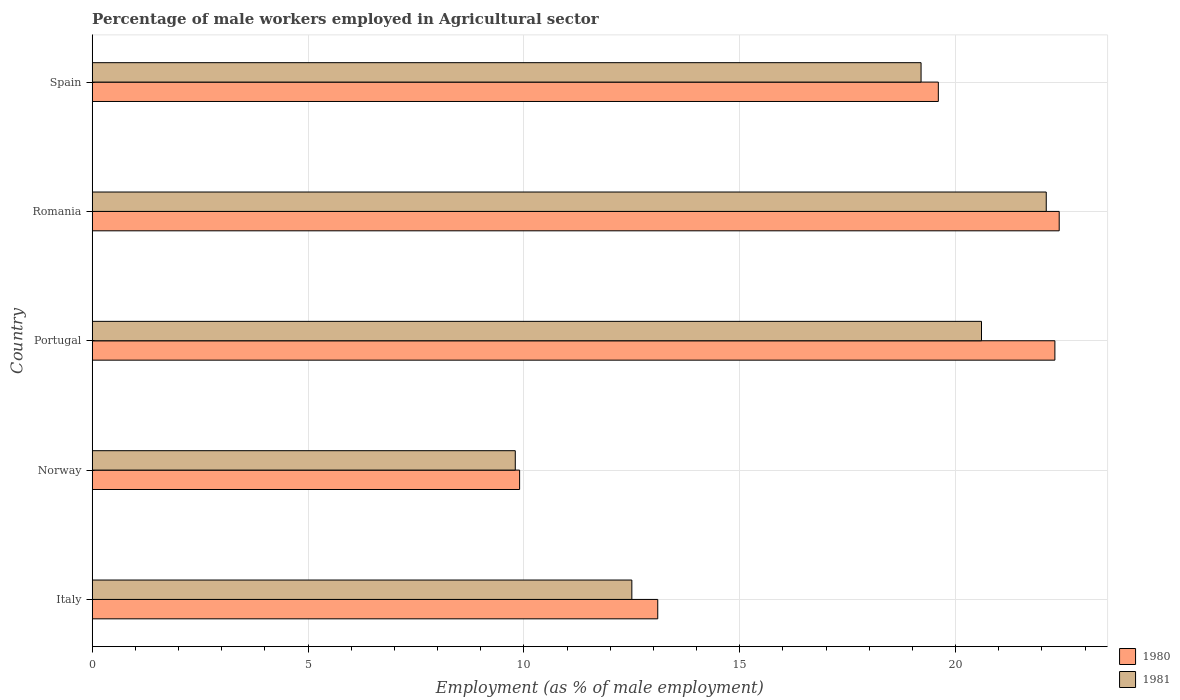How many different coloured bars are there?
Ensure brevity in your answer.  2. How many groups of bars are there?
Make the answer very short. 5. How many bars are there on the 5th tick from the top?
Your answer should be very brief. 2. In how many cases, is the number of bars for a given country not equal to the number of legend labels?
Keep it short and to the point. 0. What is the percentage of male workers employed in Agricultural sector in 1980 in Spain?
Make the answer very short. 19.6. Across all countries, what is the maximum percentage of male workers employed in Agricultural sector in 1981?
Offer a very short reply. 22.1. Across all countries, what is the minimum percentage of male workers employed in Agricultural sector in 1981?
Keep it short and to the point. 9.8. In which country was the percentage of male workers employed in Agricultural sector in 1980 maximum?
Your answer should be compact. Romania. In which country was the percentage of male workers employed in Agricultural sector in 1981 minimum?
Provide a succinct answer. Norway. What is the total percentage of male workers employed in Agricultural sector in 1981 in the graph?
Offer a very short reply. 84.2. What is the difference between the percentage of male workers employed in Agricultural sector in 1980 in Italy and that in Norway?
Your answer should be compact. 3.2. What is the difference between the percentage of male workers employed in Agricultural sector in 1981 in Portugal and the percentage of male workers employed in Agricultural sector in 1980 in Italy?
Provide a succinct answer. 7.5. What is the average percentage of male workers employed in Agricultural sector in 1981 per country?
Make the answer very short. 16.84. What is the difference between the percentage of male workers employed in Agricultural sector in 1981 and percentage of male workers employed in Agricultural sector in 1980 in Romania?
Keep it short and to the point. -0.3. In how many countries, is the percentage of male workers employed in Agricultural sector in 1980 greater than 10 %?
Your answer should be very brief. 4. What is the ratio of the percentage of male workers employed in Agricultural sector in 1980 in Norway to that in Portugal?
Your answer should be compact. 0.44. Is the percentage of male workers employed in Agricultural sector in 1980 in Norway less than that in Romania?
Ensure brevity in your answer.  Yes. Is the difference between the percentage of male workers employed in Agricultural sector in 1981 in Italy and Norway greater than the difference between the percentage of male workers employed in Agricultural sector in 1980 in Italy and Norway?
Ensure brevity in your answer.  No. What is the difference between the highest and the second highest percentage of male workers employed in Agricultural sector in 1980?
Offer a terse response. 0.1. What is the difference between the highest and the lowest percentage of male workers employed in Agricultural sector in 1981?
Your response must be concise. 12.3. What does the 1st bar from the bottom in Romania represents?
Ensure brevity in your answer.  1980. Are all the bars in the graph horizontal?
Make the answer very short. Yes. What is the difference between two consecutive major ticks on the X-axis?
Make the answer very short. 5. Are the values on the major ticks of X-axis written in scientific E-notation?
Offer a terse response. No. Does the graph contain grids?
Ensure brevity in your answer.  Yes. Where does the legend appear in the graph?
Provide a succinct answer. Bottom right. How many legend labels are there?
Your answer should be compact. 2. What is the title of the graph?
Make the answer very short. Percentage of male workers employed in Agricultural sector. What is the label or title of the X-axis?
Your response must be concise. Employment (as % of male employment). What is the label or title of the Y-axis?
Provide a succinct answer. Country. What is the Employment (as % of male employment) of 1980 in Italy?
Provide a succinct answer. 13.1. What is the Employment (as % of male employment) of 1981 in Italy?
Provide a short and direct response. 12.5. What is the Employment (as % of male employment) in 1980 in Norway?
Your answer should be very brief. 9.9. What is the Employment (as % of male employment) in 1981 in Norway?
Your answer should be very brief. 9.8. What is the Employment (as % of male employment) in 1980 in Portugal?
Your answer should be very brief. 22.3. What is the Employment (as % of male employment) in 1981 in Portugal?
Give a very brief answer. 20.6. What is the Employment (as % of male employment) of 1980 in Romania?
Provide a succinct answer. 22.4. What is the Employment (as % of male employment) in 1981 in Romania?
Keep it short and to the point. 22.1. What is the Employment (as % of male employment) of 1980 in Spain?
Offer a very short reply. 19.6. What is the Employment (as % of male employment) in 1981 in Spain?
Your answer should be very brief. 19.2. Across all countries, what is the maximum Employment (as % of male employment) in 1980?
Provide a succinct answer. 22.4. Across all countries, what is the maximum Employment (as % of male employment) of 1981?
Your answer should be very brief. 22.1. Across all countries, what is the minimum Employment (as % of male employment) of 1980?
Your answer should be compact. 9.9. Across all countries, what is the minimum Employment (as % of male employment) of 1981?
Ensure brevity in your answer.  9.8. What is the total Employment (as % of male employment) of 1980 in the graph?
Your answer should be very brief. 87.3. What is the total Employment (as % of male employment) in 1981 in the graph?
Offer a very short reply. 84.2. What is the difference between the Employment (as % of male employment) of 1980 in Italy and that in Romania?
Make the answer very short. -9.3. What is the difference between the Employment (as % of male employment) of 1981 in Italy and that in Romania?
Your answer should be compact. -9.6. What is the difference between the Employment (as % of male employment) of 1980 in Italy and that in Spain?
Offer a very short reply. -6.5. What is the difference between the Employment (as % of male employment) of 1980 in Norway and that in Spain?
Make the answer very short. -9.7. What is the difference between the Employment (as % of male employment) in 1980 in Portugal and that in Romania?
Your answer should be very brief. -0.1. What is the difference between the Employment (as % of male employment) in 1980 in Romania and that in Spain?
Make the answer very short. 2.8. What is the difference between the Employment (as % of male employment) of 1981 in Romania and that in Spain?
Provide a short and direct response. 2.9. What is the difference between the Employment (as % of male employment) in 1980 in Italy and the Employment (as % of male employment) in 1981 in Portugal?
Your response must be concise. -7.5. What is the difference between the Employment (as % of male employment) in 1980 in Italy and the Employment (as % of male employment) in 1981 in Spain?
Your answer should be very brief. -6.1. What is the difference between the Employment (as % of male employment) of 1980 in Norway and the Employment (as % of male employment) of 1981 in Portugal?
Your response must be concise. -10.7. What is the difference between the Employment (as % of male employment) of 1980 in Norway and the Employment (as % of male employment) of 1981 in Romania?
Your answer should be very brief. -12.2. What is the difference between the Employment (as % of male employment) of 1980 in Portugal and the Employment (as % of male employment) of 1981 in Spain?
Ensure brevity in your answer.  3.1. What is the difference between the Employment (as % of male employment) in 1980 in Romania and the Employment (as % of male employment) in 1981 in Spain?
Give a very brief answer. 3.2. What is the average Employment (as % of male employment) in 1980 per country?
Provide a succinct answer. 17.46. What is the average Employment (as % of male employment) in 1981 per country?
Ensure brevity in your answer.  16.84. What is the difference between the Employment (as % of male employment) of 1980 and Employment (as % of male employment) of 1981 in Norway?
Keep it short and to the point. 0.1. What is the difference between the Employment (as % of male employment) in 1980 and Employment (as % of male employment) in 1981 in Portugal?
Your answer should be compact. 1.7. What is the difference between the Employment (as % of male employment) in 1980 and Employment (as % of male employment) in 1981 in Romania?
Provide a short and direct response. 0.3. What is the difference between the Employment (as % of male employment) of 1980 and Employment (as % of male employment) of 1981 in Spain?
Provide a succinct answer. 0.4. What is the ratio of the Employment (as % of male employment) in 1980 in Italy to that in Norway?
Your answer should be very brief. 1.32. What is the ratio of the Employment (as % of male employment) in 1981 in Italy to that in Norway?
Ensure brevity in your answer.  1.28. What is the ratio of the Employment (as % of male employment) in 1980 in Italy to that in Portugal?
Offer a terse response. 0.59. What is the ratio of the Employment (as % of male employment) in 1981 in Italy to that in Portugal?
Offer a terse response. 0.61. What is the ratio of the Employment (as % of male employment) of 1980 in Italy to that in Romania?
Provide a succinct answer. 0.58. What is the ratio of the Employment (as % of male employment) in 1981 in Italy to that in Romania?
Make the answer very short. 0.57. What is the ratio of the Employment (as % of male employment) in 1980 in Italy to that in Spain?
Your answer should be very brief. 0.67. What is the ratio of the Employment (as % of male employment) in 1981 in Italy to that in Spain?
Offer a terse response. 0.65. What is the ratio of the Employment (as % of male employment) in 1980 in Norway to that in Portugal?
Ensure brevity in your answer.  0.44. What is the ratio of the Employment (as % of male employment) of 1981 in Norway to that in Portugal?
Give a very brief answer. 0.48. What is the ratio of the Employment (as % of male employment) in 1980 in Norway to that in Romania?
Provide a succinct answer. 0.44. What is the ratio of the Employment (as % of male employment) of 1981 in Norway to that in Romania?
Provide a short and direct response. 0.44. What is the ratio of the Employment (as % of male employment) in 1980 in Norway to that in Spain?
Make the answer very short. 0.51. What is the ratio of the Employment (as % of male employment) of 1981 in Norway to that in Spain?
Keep it short and to the point. 0.51. What is the ratio of the Employment (as % of male employment) of 1980 in Portugal to that in Romania?
Provide a short and direct response. 1. What is the ratio of the Employment (as % of male employment) of 1981 in Portugal to that in Romania?
Make the answer very short. 0.93. What is the ratio of the Employment (as % of male employment) in 1980 in Portugal to that in Spain?
Your response must be concise. 1.14. What is the ratio of the Employment (as % of male employment) in 1981 in Portugal to that in Spain?
Your answer should be very brief. 1.07. What is the ratio of the Employment (as % of male employment) in 1981 in Romania to that in Spain?
Your answer should be compact. 1.15. What is the difference between the highest and the second highest Employment (as % of male employment) in 1981?
Provide a short and direct response. 1.5. What is the difference between the highest and the lowest Employment (as % of male employment) in 1981?
Keep it short and to the point. 12.3. 